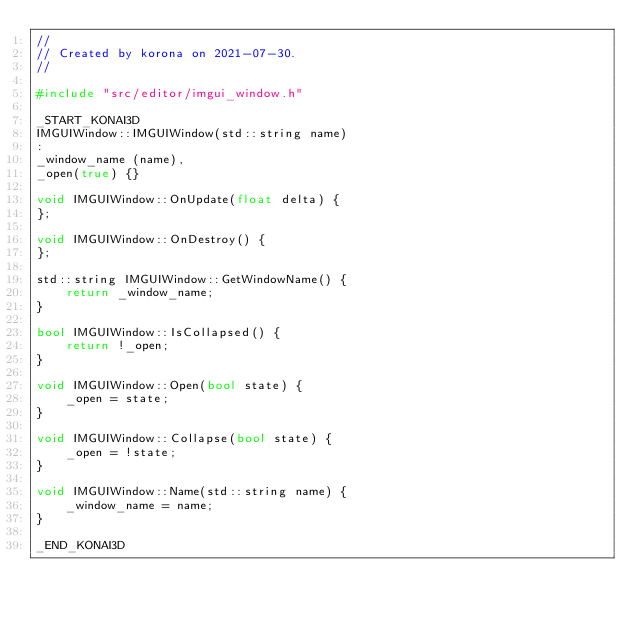Convert code to text. <code><loc_0><loc_0><loc_500><loc_500><_C++_>//
// Created by korona on 2021-07-30.
//

#include "src/editor/imgui_window.h"

_START_KONAI3D
IMGUIWindow::IMGUIWindow(std::string name)
:
_window_name (name),
_open(true) {}

void IMGUIWindow::OnUpdate(float delta) {
};

void IMGUIWindow::OnDestroy() {
};

std::string IMGUIWindow::GetWindowName() {
    return _window_name;
}

bool IMGUIWindow::IsCollapsed() {
    return !_open;
}

void IMGUIWindow::Open(bool state) {
    _open = state;
}

void IMGUIWindow::Collapse(bool state) {
    _open = !state;
}

void IMGUIWindow::Name(std::string name) {
    _window_name = name;
}

_END_KONAI3D</code> 